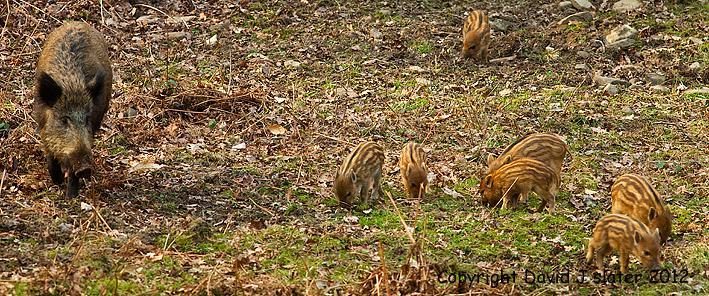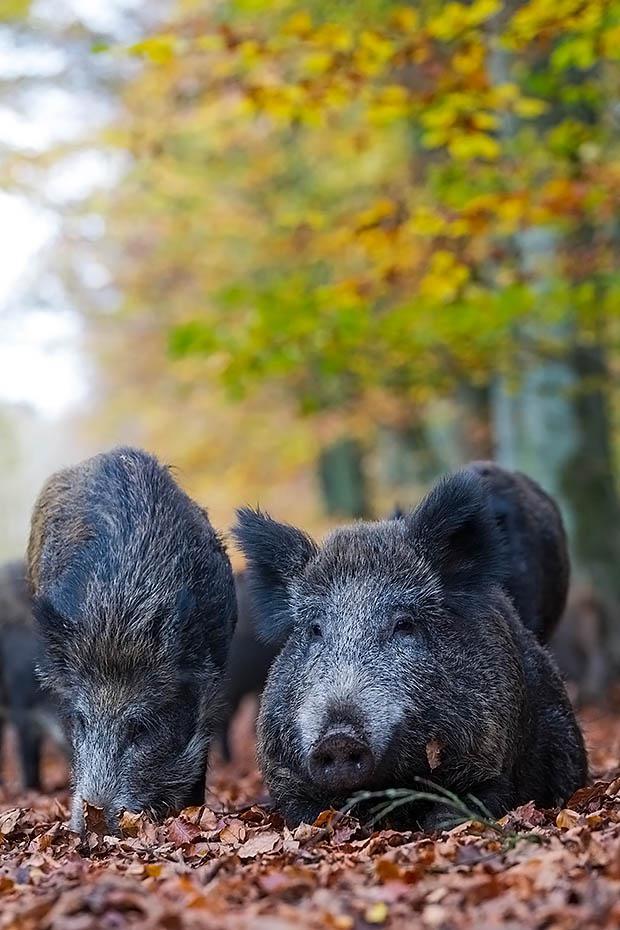The first image is the image on the left, the second image is the image on the right. Evaluate the accuracy of this statement regarding the images: "The left image contains no more than five wild boars.". Is it true? Answer yes or no. No. The first image is the image on the left, the second image is the image on the right. For the images shown, is this caption "Piglets are standing beside an adult pig in both images." true? Answer yes or no. No. 